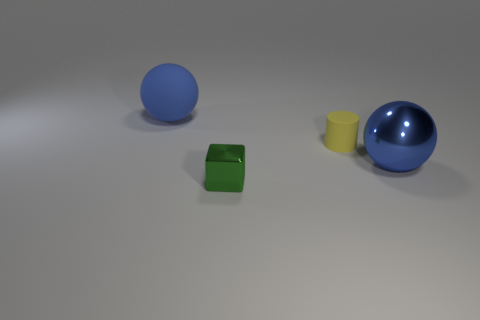There is a metal sphere that is the same color as the big rubber object; what is its size?
Offer a very short reply. Large. There is a small green object; is its shape the same as the large blue thing on the right side of the green metal cube?
Your answer should be compact. No. The matte ball that is the same size as the blue metallic thing is what color?
Your response must be concise. Blue. Is the number of tiny yellow objects that are on the left side of the blue rubber sphere less than the number of yellow things that are right of the tiny yellow matte object?
Make the answer very short. No. What shape is the shiny thing left of the ball on the right side of the blue object that is behind the large blue metal object?
Ensure brevity in your answer.  Cube. Is the color of the metal object to the right of the yellow matte cylinder the same as the matte thing that is in front of the large matte thing?
Your answer should be compact. No. There is a shiny object that is the same color as the large matte ball; what shape is it?
Keep it short and to the point. Sphere. How many matte things are either green blocks or large gray objects?
Keep it short and to the point. 0. What is the color of the big ball that is behind the rubber thing that is in front of the blue thing that is on the left side of the tiny green metallic cube?
Offer a terse response. Blue. What is the color of the other big thing that is the same shape as the large blue rubber object?
Your response must be concise. Blue. 